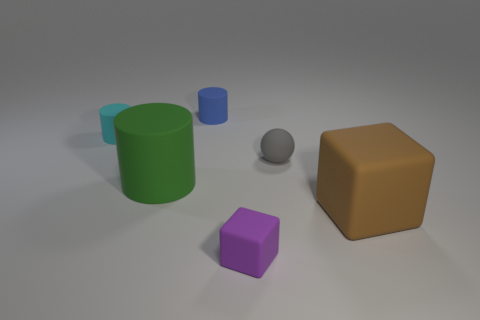Subtract all blue cylinders. How many cylinders are left? 2 Subtract all green cylinders. How many cylinders are left? 2 Add 1 large brown things. How many objects exist? 7 Subtract 1 cylinders. How many cylinders are left? 2 Subtract all purple cylinders. Subtract all yellow blocks. How many cylinders are left? 3 Subtract all balls. How many objects are left? 5 Subtract 0 brown spheres. How many objects are left? 6 Subtract all tiny gray rubber things. Subtract all cyan cylinders. How many objects are left? 4 Add 2 small cyan matte objects. How many small cyan matte objects are left? 3 Add 3 tiny purple objects. How many tiny purple objects exist? 4 